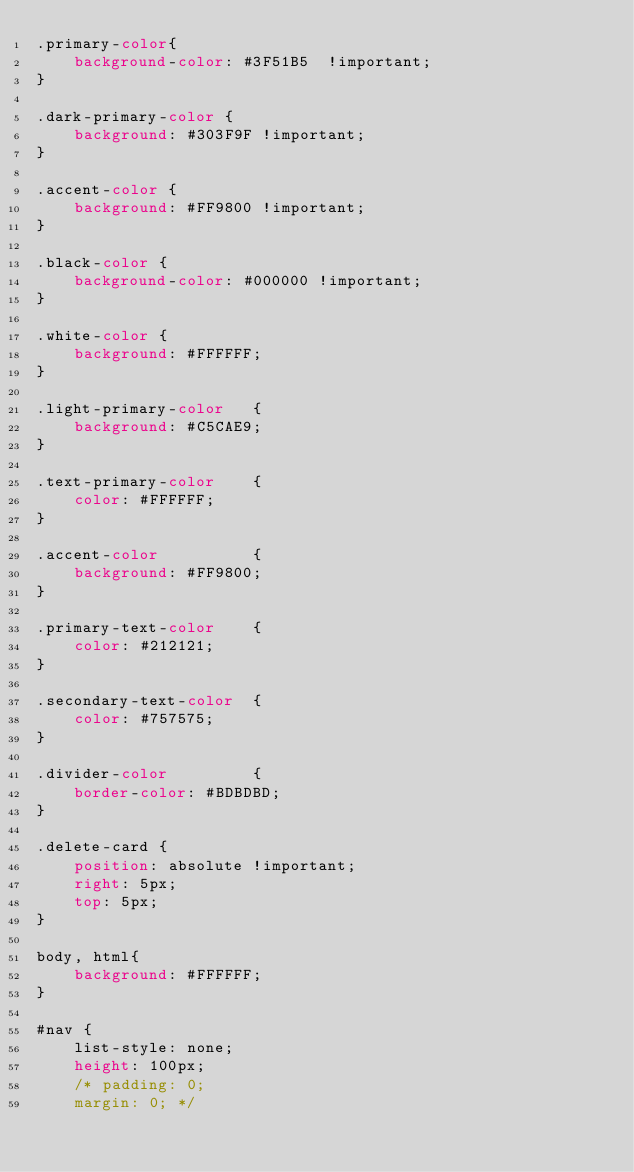Convert code to text. <code><loc_0><loc_0><loc_500><loc_500><_CSS_>.primary-color{
    background-color: #3F51B5  !important;
}

.dark-primary-color {
    background: #303F9F !important;
}

.accent-color {
    background: #FF9800 !important;
}

.black-color {
    background-color: #000000 !important;
}

.white-color {
    background: #FFFFFF;
}

.light-primary-color   { 
    background: #C5CAE9; 
}

.text-primary-color    {
    color: #FFFFFF; 
}

.accent-color          { 
    background: #FF9800; 
}

.primary-text-color    { 
    color: #212121; 
}

.secondary-text-color  {
    color: #757575; 
}

.divider-color         { 
    border-color: #BDBDBD; 
}

.delete-card {
    position: absolute !important;
    right: 5px;
    top: 5px;
}

body, html{
    background: #FFFFFF;
}

#nav {
    list-style: none;
    height: 100px;
    /* padding: 0;
    margin: 0; */</code> 